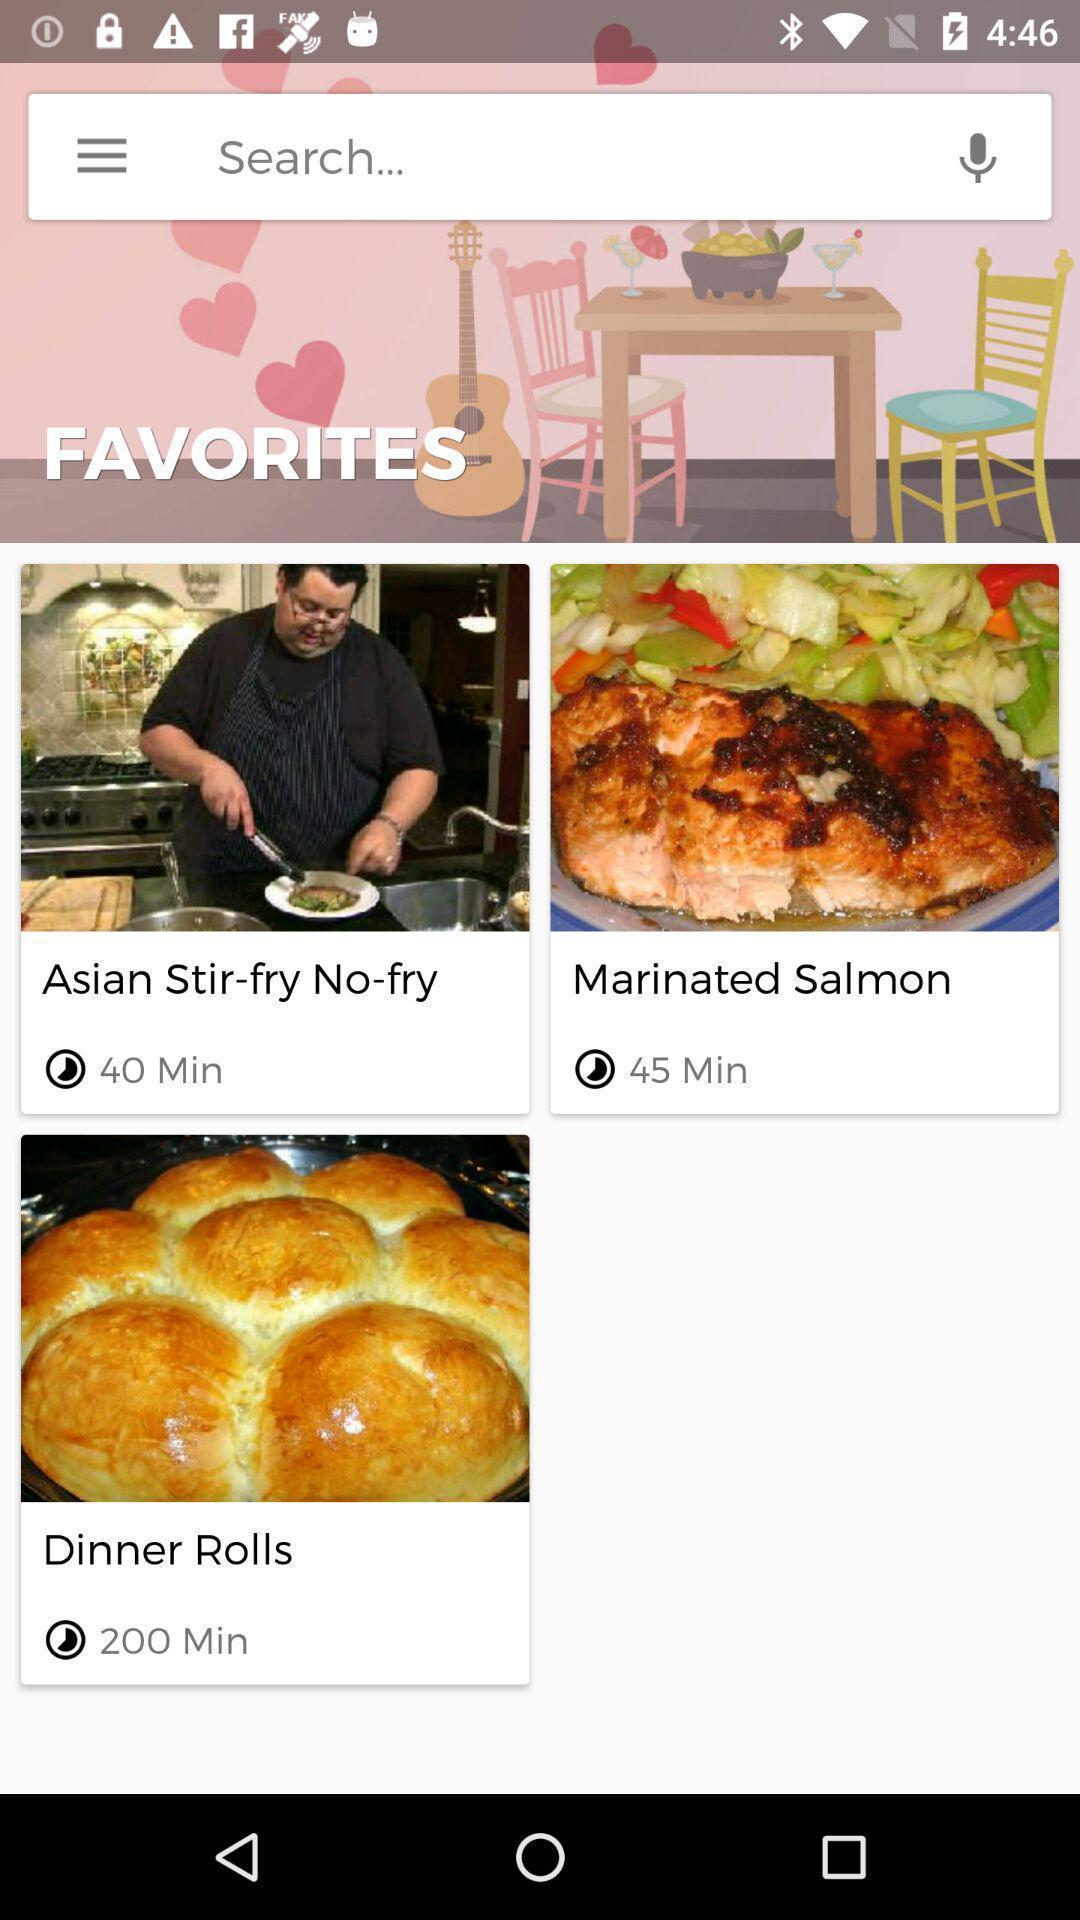Describe the visual elements of this screenshot. Search page of a food items app. 